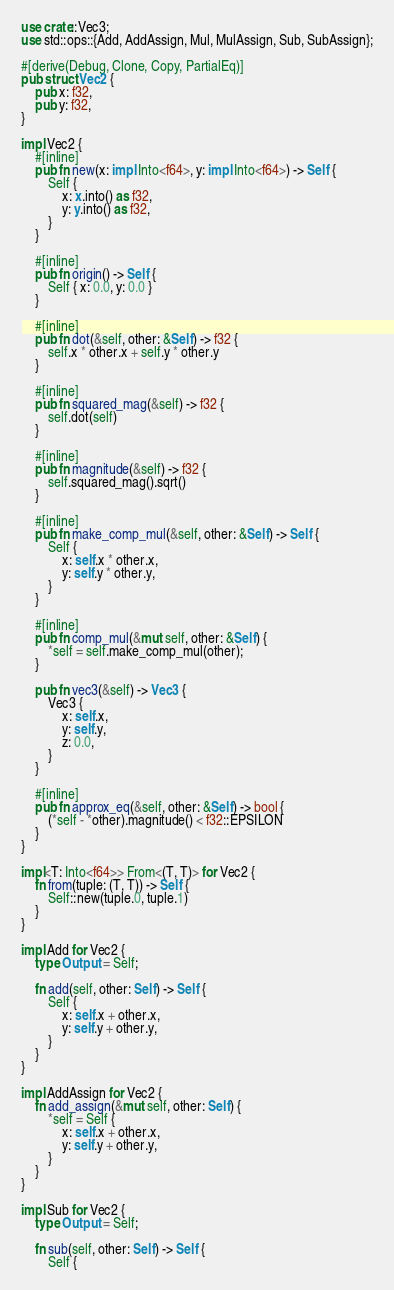Convert code to text. <code><loc_0><loc_0><loc_500><loc_500><_Rust_>use crate::Vec3;
use std::ops::{Add, AddAssign, Mul, MulAssign, Sub, SubAssign};

#[derive(Debug, Clone, Copy, PartialEq)]
pub struct Vec2 {
    pub x: f32,
    pub y: f32,
}

impl Vec2 {
    #[inline]
    pub fn new(x: impl Into<f64>, y: impl Into<f64>) -> Self {
        Self {
            x: x.into() as f32,
            y: y.into() as f32,
        }
    }

    #[inline]
    pub fn origin() -> Self {
        Self { x: 0.0, y: 0.0 }
    }

    #[inline]
    pub fn dot(&self, other: &Self) -> f32 {
        self.x * other.x + self.y * other.y
    }

    #[inline]
    pub fn squared_mag(&self) -> f32 {
        self.dot(self)
    }

    #[inline]
    pub fn magnitude(&self) -> f32 {
        self.squared_mag().sqrt()
    }

    #[inline]
    pub fn make_comp_mul(&self, other: &Self) -> Self {
        Self {
            x: self.x * other.x,
            y: self.y * other.y,
        }
    }

    #[inline]
    pub fn comp_mul(&mut self, other: &Self) {
        *self = self.make_comp_mul(other);
    }

    pub fn vec3(&self) -> Vec3 {
        Vec3 {
            x: self.x,
            y: self.y,
            z: 0.0,
        }
    }

    #[inline]
    pub fn approx_eq(&self, other: &Self) -> bool {
        (*self - *other).magnitude() < f32::EPSILON
    }
}

impl<T: Into<f64>> From<(T, T)> for Vec2 {
    fn from(tuple: (T, T)) -> Self {
        Self::new(tuple.0, tuple.1)
    }
}

impl Add for Vec2 {
    type Output = Self;

    fn add(self, other: Self) -> Self {
        Self {
            x: self.x + other.x,
            y: self.y + other.y,
        }
    }
}

impl AddAssign for Vec2 {
    fn add_assign(&mut self, other: Self) {
        *self = Self {
            x: self.x + other.x,
            y: self.y + other.y,
        }
    }
}

impl Sub for Vec2 {
    type Output = Self;

    fn sub(self, other: Self) -> Self {
        Self {</code> 